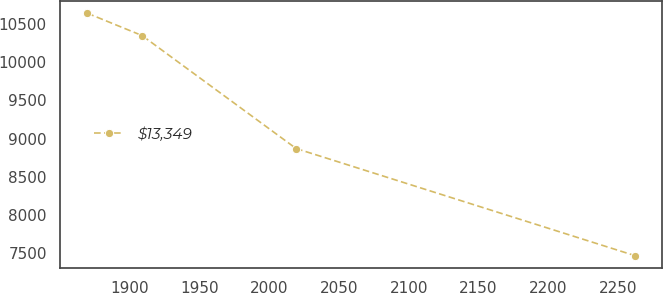Convert chart to OTSL. <chart><loc_0><loc_0><loc_500><loc_500><line_chart><ecel><fcel>$13,349<nl><fcel>1869.7<fcel>10641.3<nl><fcel>1908.92<fcel>10348.9<nl><fcel>2019.35<fcel>8870.1<nl><fcel>2261.93<fcel>7469.93<nl></chart> 